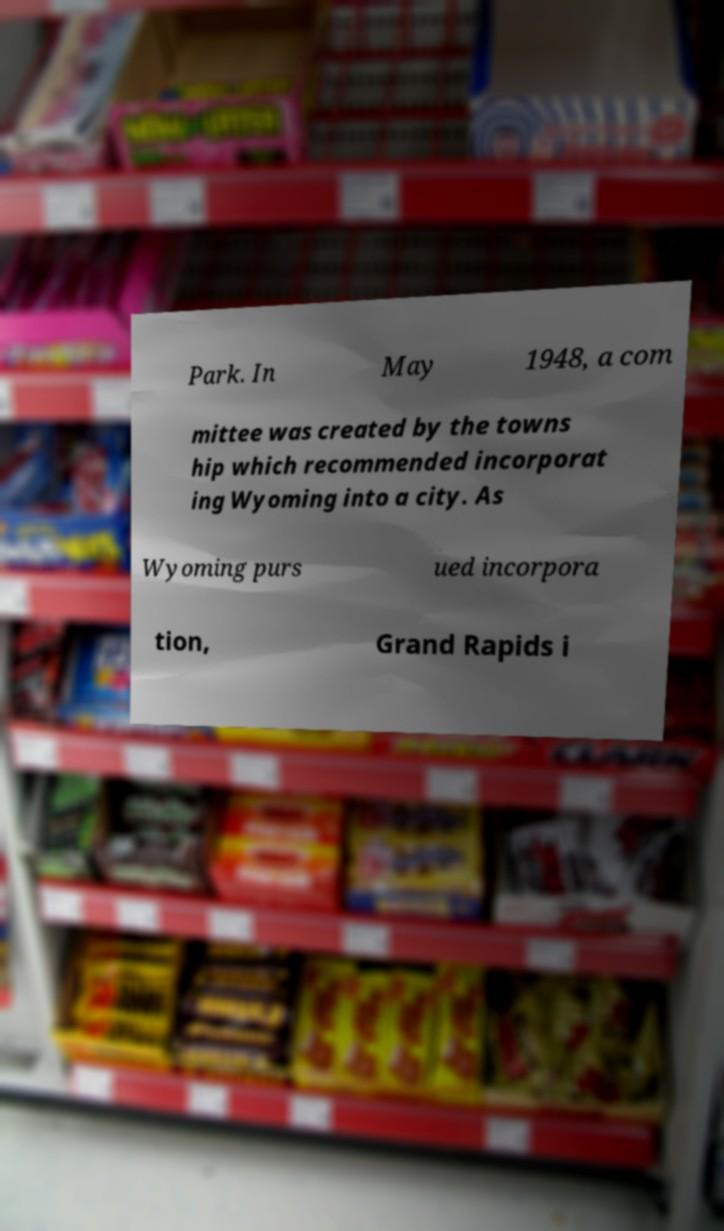For documentation purposes, I need the text within this image transcribed. Could you provide that? Park. In May 1948, a com mittee was created by the towns hip which recommended incorporat ing Wyoming into a city. As Wyoming purs ued incorpora tion, Grand Rapids i 